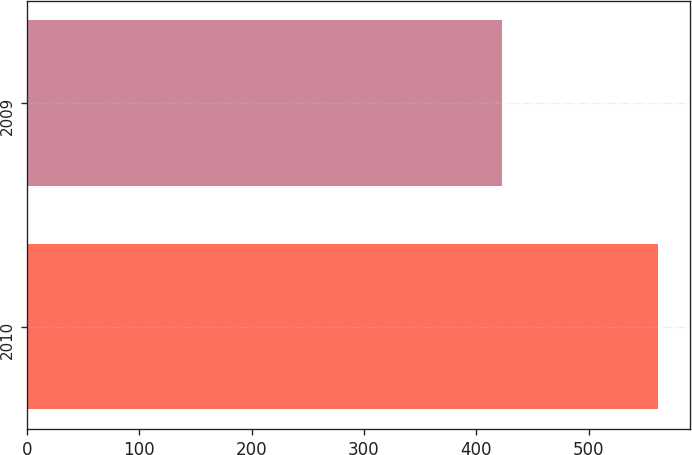Convert chart. <chart><loc_0><loc_0><loc_500><loc_500><bar_chart><fcel>2010<fcel>2009<nl><fcel>562<fcel>423<nl></chart> 